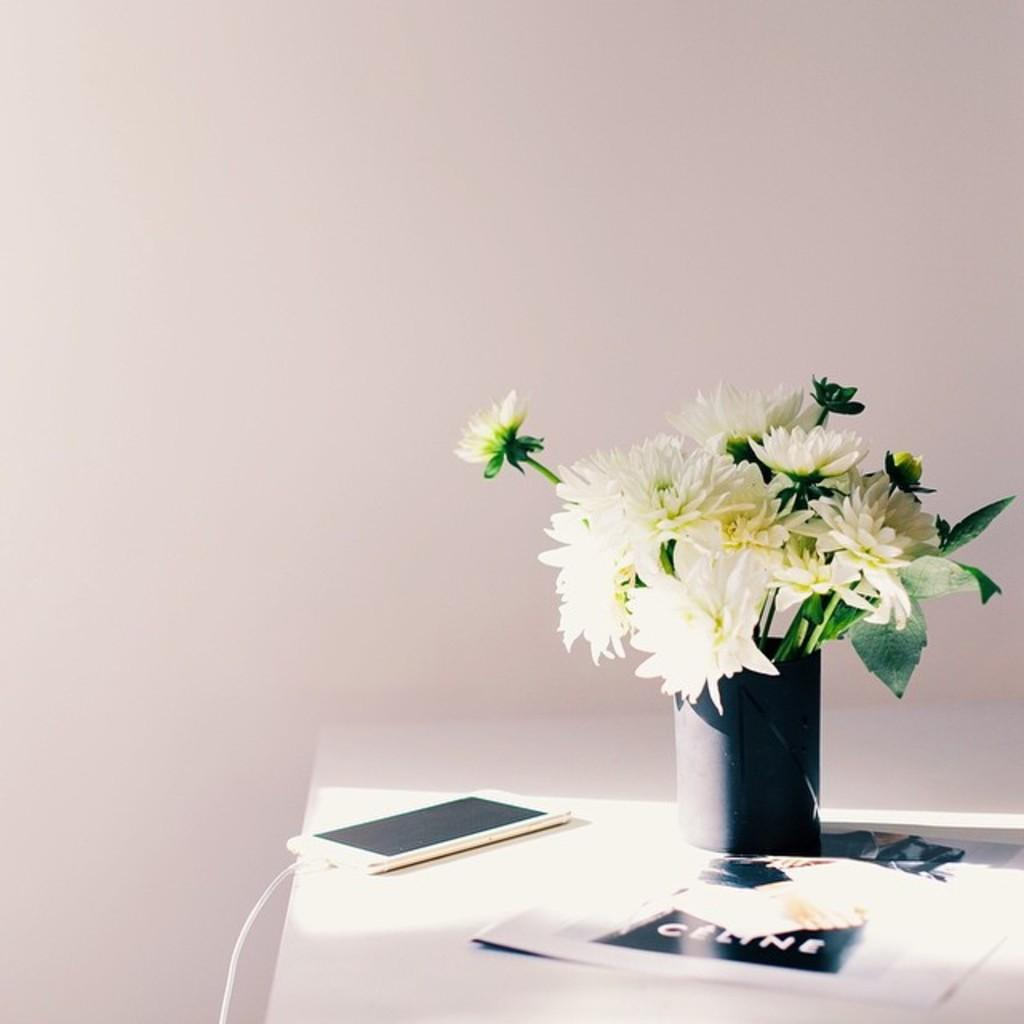What type of furniture is present in the image? There is a table in the image. What is placed on the table? There is a vase on the table, and the vase contains flowers. What electronic device is also present on the table? There is a mobile phone on the table. What holiday is being celebrated in the image? There is no indication of a holiday being celebrated in the image; the image only shows a table with a vase, flowers, and a mobile phone. 